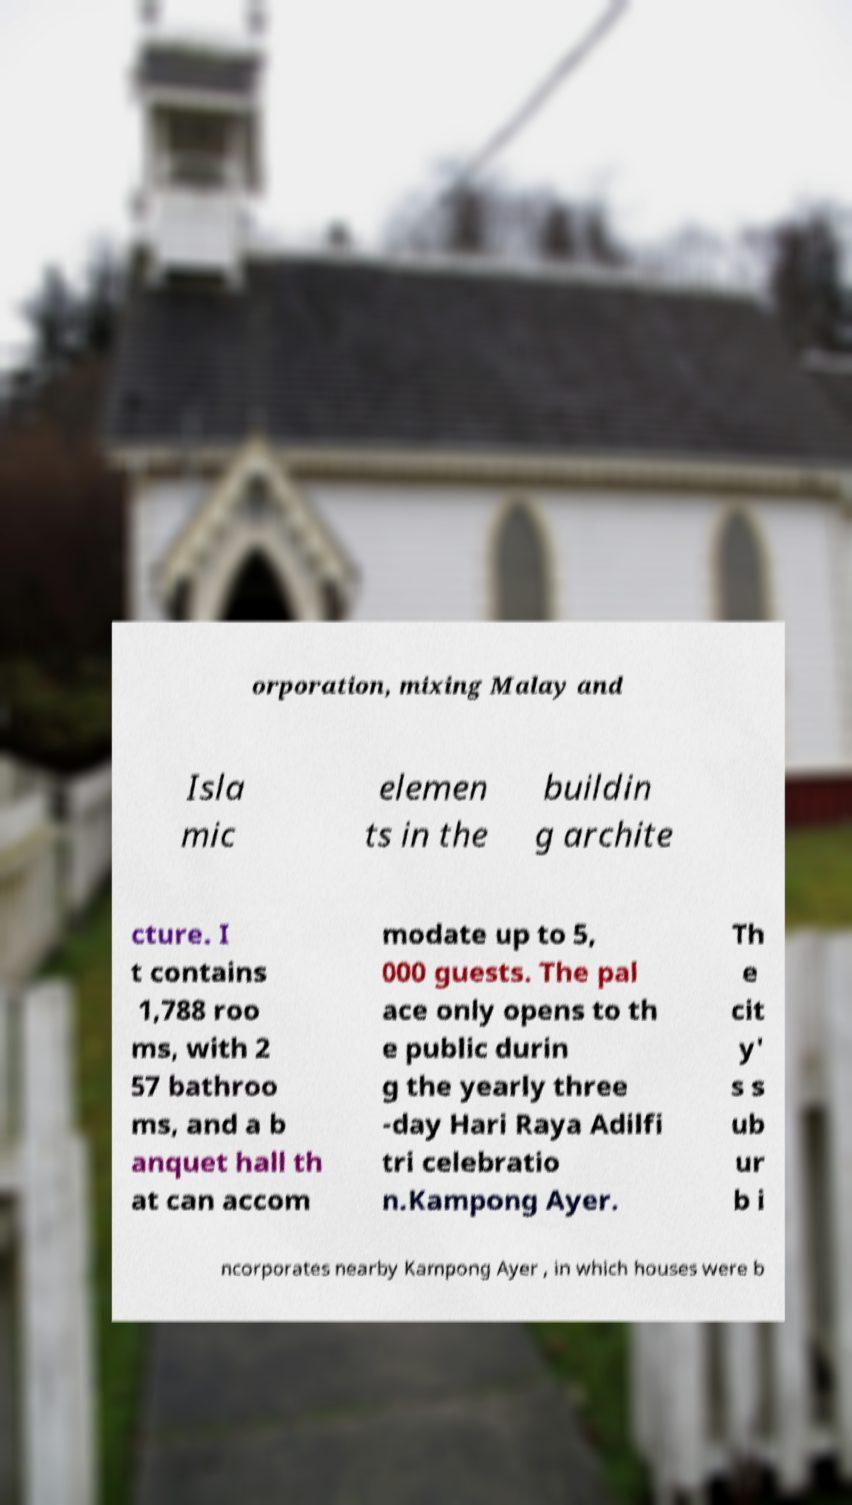I need the written content from this picture converted into text. Can you do that? orporation, mixing Malay and Isla mic elemen ts in the buildin g archite cture. I t contains 1,788 roo ms, with 2 57 bathroo ms, and a b anquet hall th at can accom modate up to 5, 000 guests. The pal ace only opens to th e public durin g the yearly three -day Hari Raya Adilfi tri celebratio n.Kampong Ayer. Th e cit y' s s ub ur b i ncorporates nearby Kampong Ayer , in which houses were b 